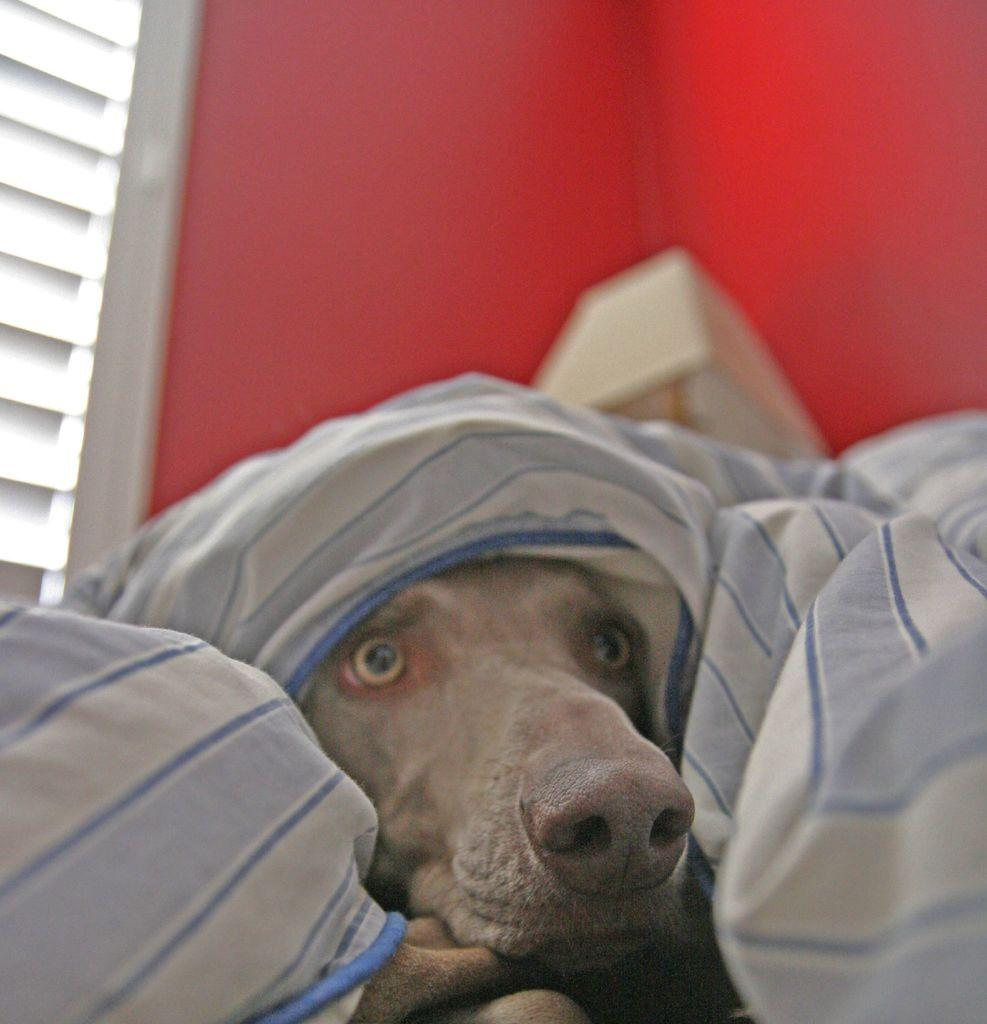What type of animal can be seen in the image? There is a dog in the image. Where is the dog located in the image? The dog is hiding under a bed sheet. What color is the wall in the image? There is a red wall in the image. What type of lighting is present in the image? There is a lamp in the image. What feature allows natural light to enter the room in the image? There is a window in the image. What type of hose can be seen spraying water on the dog in the image? There is no hose present in the image, and the dog is not being sprayed with water. What type of fog can be seen surrounding the dog in the image? There is no fog present in the image; the dog is hiding under a bed sheet. 